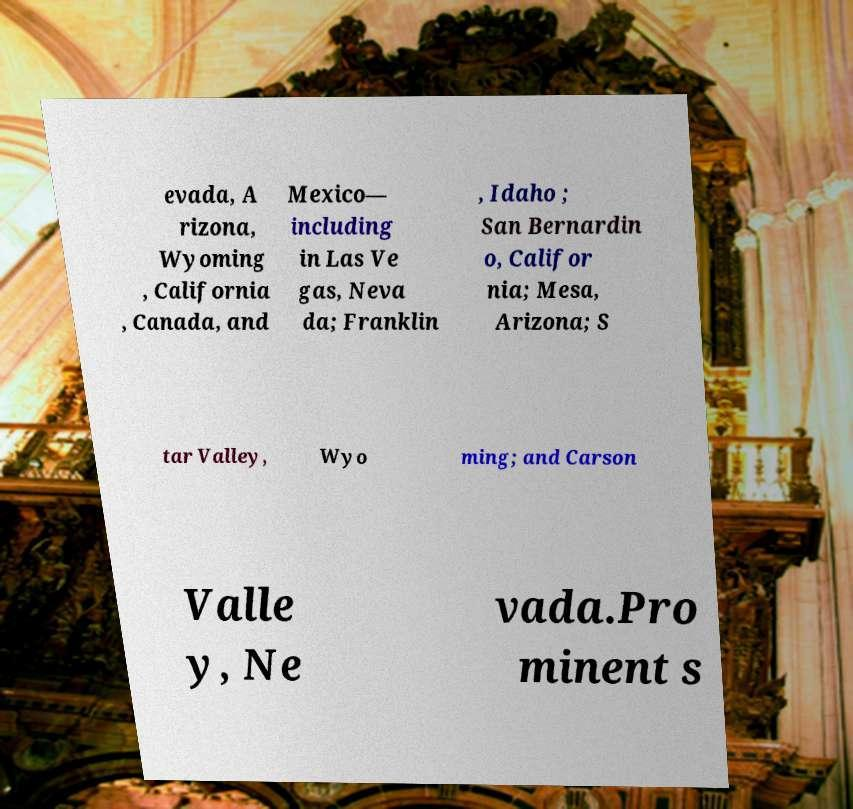What messages or text are displayed in this image? I need them in a readable, typed format. evada, A rizona, Wyoming , California , Canada, and Mexico— including in Las Ve gas, Neva da; Franklin , Idaho ; San Bernardin o, Califor nia; Mesa, Arizona; S tar Valley, Wyo ming; and Carson Valle y, Ne vada.Pro minent s 